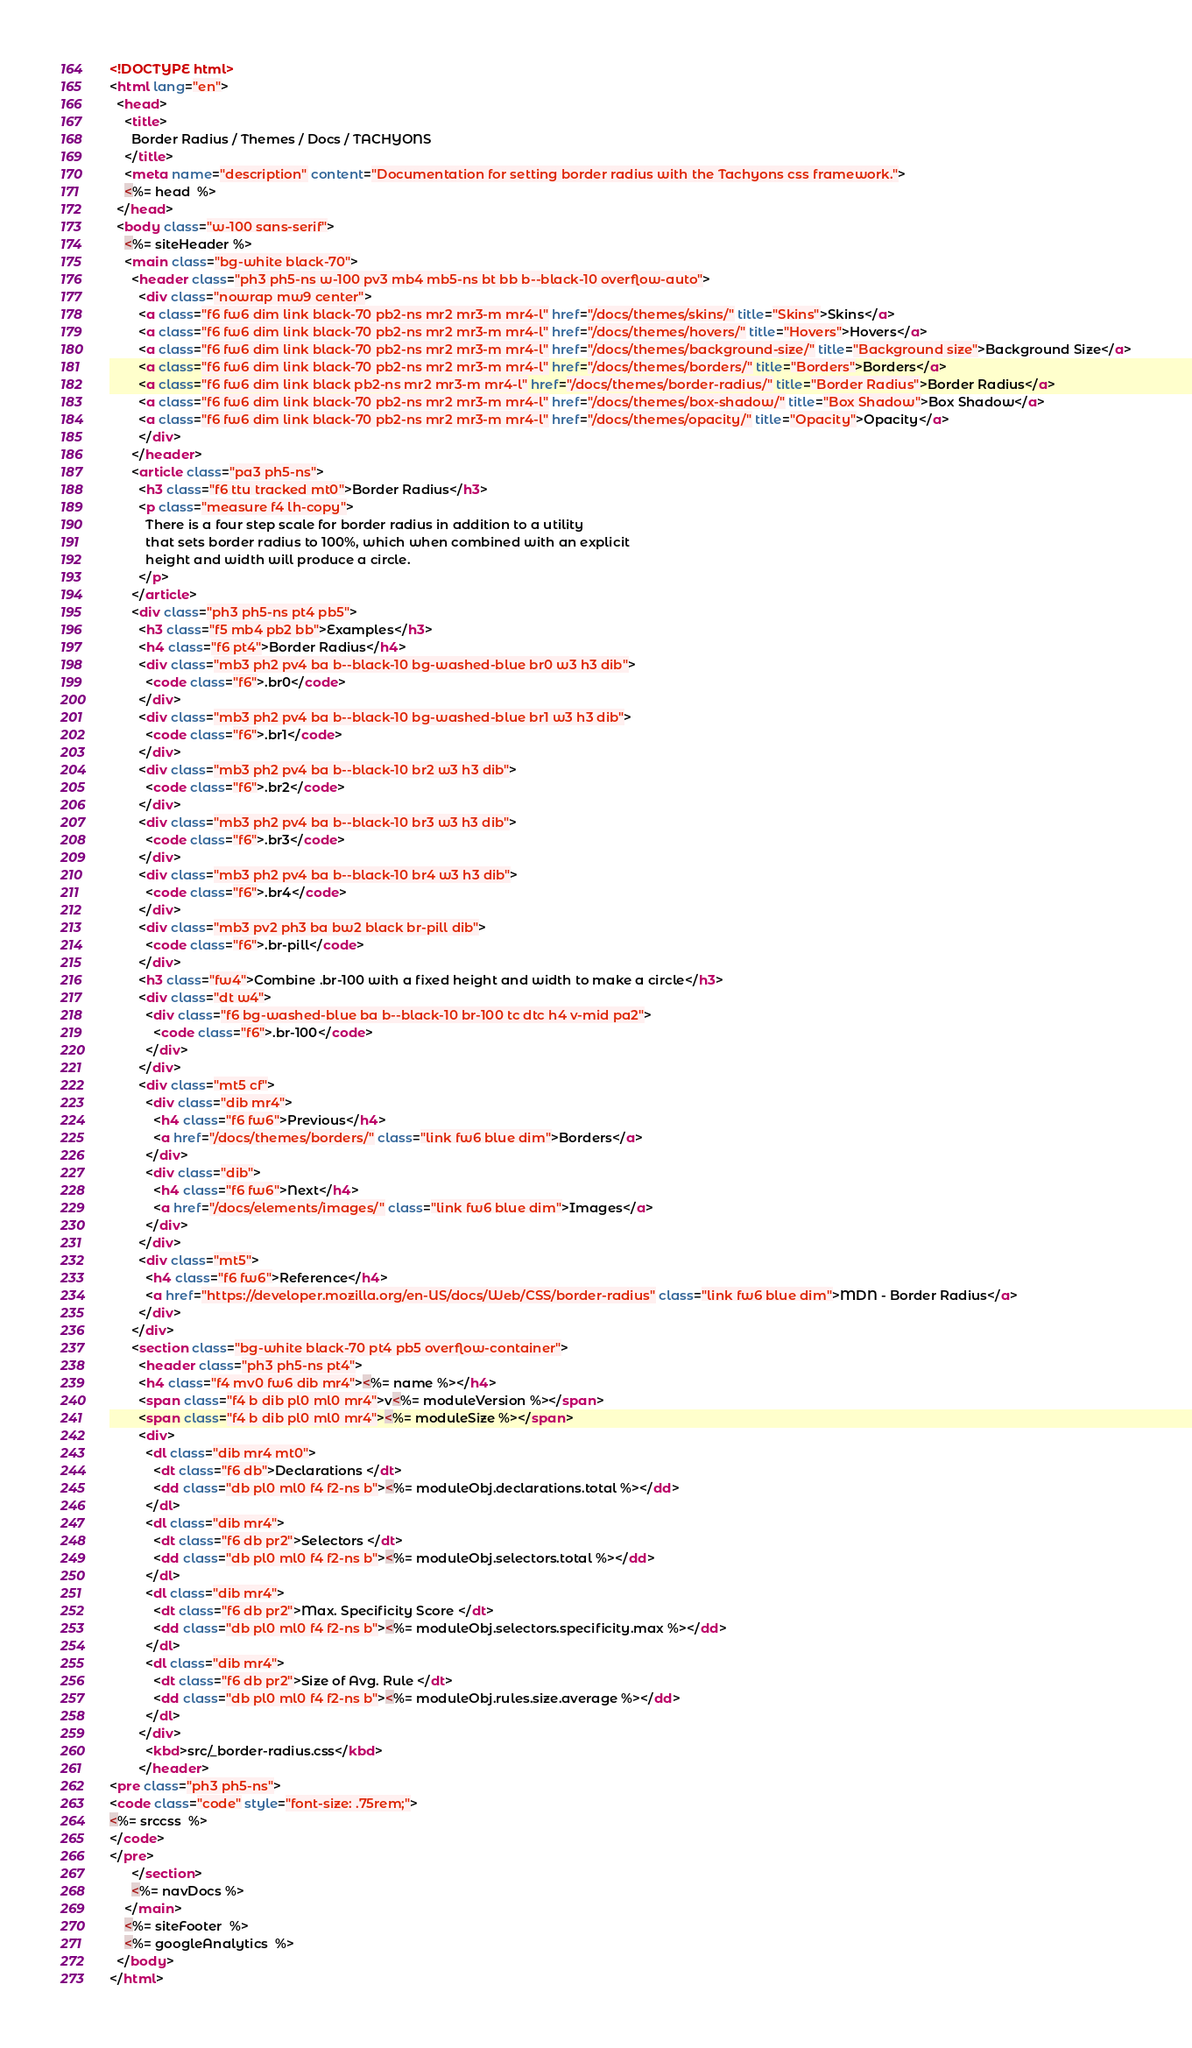<code> <loc_0><loc_0><loc_500><loc_500><_HTML_><!DOCTYPE html>
<html lang="en">
  <head>
    <title>
      Border Radius / Themes / Docs / TACHYONS
    </title>
    <meta name="description" content="Documentation for setting border radius with the Tachyons css framework.">
    <%= head  %>
  </head>
  <body class="w-100 sans-serif">
    <%= siteHeader %>
    <main class="bg-white black-70">
      <header class="ph3 ph5-ns w-100 pv3 mb4 mb5-ns bt bb b--black-10 overflow-auto">
        <div class="nowrap mw9 center">
        <a class="f6 fw6 dim link black-70 pb2-ns mr2 mr3-m mr4-l" href="/docs/themes/skins/" title="Skins">Skins</a>
        <a class="f6 fw6 dim link black-70 pb2-ns mr2 mr3-m mr4-l" href="/docs/themes/hovers/" title="Hovers">Hovers</a>
        <a class="f6 fw6 dim link black-70 pb2-ns mr2 mr3-m mr4-l" href="/docs/themes/background-size/" title="Background size">Background Size</a>
        <a class="f6 fw6 dim link black-70 pb2-ns mr2 mr3-m mr4-l" href="/docs/themes/borders/" title="Borders">Borders</a>
        <a class="f6 fw6 dim link black pb2-ns mr2 mr3-m mr4-l" href="/docs/themes/border-radius/" title="Border Radius">Border Radius</a>
        <a class="f6 fw6 dim link black-70 pb2-ns mr2 mr3-m mr4-l" href="/docs/themes/box-shadow/" title="Box Shadow">Box Shadow</a>
        <a class="f6 fw6 dim link black-70 pb2-ns mr2 mr3-m mr4-l" href="/docs/themes/opacity/" title="Opacity">Opacity</a>
        </div>
      </header>
      <article class="pa3 ph5-ns">
        <h3 class="f6 ttu tracked mt0">Border Radius</h3>
        <p class="measure f4 lh-copy">
          There is a four step scale for border radius in addition to a utility
          that sets border radius to 100%, which when combined with an explicit
          height and width will produce a circle.
        </p>
      </article>
      <div class="ph3 ph5-ns pt4 pb5">
        <h3 class="f5 mb4 pb2 bb">Examples</h3>
        <h4 class="f6 pt4">Border Radius</h4>
        <div class="mb3 ph2 pv4 ba b--black-10 bg-washed-blue br0 w3 h3 dib">
          <code class="f6">.br0</code>
        </div>
        <div class="mb3 ph2 pv4 ba b--black-10 bg-washed-blue br1 w3 h3 dib">
          <code class="f6">.br1</code>
        </div>
        <div class="mb3 ph2 pv4 ba b--black-10 br2 w3 h3 dib">
          <code class="f6">.br2</code>
        </div>
        <div class="mb3 ph2 pv4 ba b--black-10 br3 w3 h3 dib">
          <code class="f6">.br3</code>
        </div>
        <div class="mb3 ph2 pv4 ba b--black-10 br4 w3 h3 dib">
          <code class="f6">.br4</code>
        </div>
        <div class="mb3 pv2 ph3 ba bw2 black br-pill dib">
          <code class="f6">.br-pill</code>
        </div>
        <h3 class="fw4">Combine .br-100 with a fixed height and width to make a circle</h3>
        <div class="dt w4">
          <div class="f6 bg-washed-blue ba b--black-10 br-100 tc dtc h4 v-mid pa2">
            <code class="f6">.br-100</code>
          </div>
        </div>
        <div class="mt5 cf">
          <div class="dib mr4">
            <h4 class="f6 fw6">Previous</h4>
            <a href="/docs/themes/borders/" class="link fw6 blue dim">Borders</a>
          </div>
          <div class="dib">
            <h4 class="f6 fw6">Next</h4>
            <a href="/docs/elements/images/" class="link fw6 blue dim">Images</a>
          </div>
        </div>
        <div class="mt5">
          <h4 class="f6 fw6">Reference</h4>
          <a href="https://developer.mozilla.org/en-US/docs/Web/CSS/border-radius" class="link fw6 blue dim">MDN - Border Radius</a>
        </div>
      </div>
      <section class="bg-white black-70 pt4 pb5 overflow-container">
        <header class="ph3 ph5-ns pt4">
        <h4 class="f4 mv0 fw6 dib mr4"><%= name %></h4>
        <span class="f4 b dib pl0 ml0 mr4">v<%= moduleVersion %></span>
        <span class="f4 b dib pl0 ml0 mr4"><%= moduleSize %></span>
        <div>
          <dl class="dib mr4 mt0">
            <dt class="f6 db">Declarations </dt>
            <dd class="db pl0 ml0 f4 f2-ns b"><%= moduleObj.declarations.total %></dd>
          </dl>
          <dl class="dib mr4">
            <dt class="f6 db pr2">Selectors </dt>
            <dd class="db pl0 ml0 f4 f2-ns b"><%= moduleObj.selectors.total %></dd>
          </dl>
          <dl class="dib mr4">
            <dt class="f6 db pr2">Max. Specificity Score </dt>
            <dd class="db pl0 ml0 f4 f2-ns b"><%= moduleObj.selectors.specificity.max %></dd>
          </dl>
          <dl class="dib mr4">
            <dt class="f6 db pr2">Size of Avg. Rule </dt>
            <dd class="db pl0 ml0 f4 f2-ns b"><%= moduleObj.rules.size.average %></dd>
          </dl>
        </div>
          <kbd>src/_border-radius.css</kbd>
        </header>
<pre class="ph3 ph5-ns">
<code class="code" style="font-size: .75rem;">
<%= srccss  %>
</code>
</pre>
      </section>
      <%= navDocs %>
    </main>
    <%= siteFooter  %>
    <%= googleAnalytics  %>
  </body>
</html>
</code> 